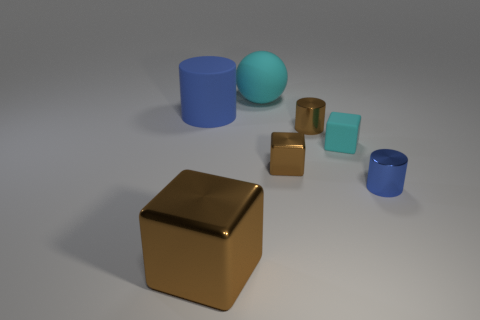Add 2 large blue rubber things. How many objects exist? 9 Subtract all cylinders. How many objects are left? 4 Subtract 2 brown blocks. How many objects are left? 5 Subtract all large red matte cylinders. Subtract all tiny brown cylinders. How many objects are left? 6 Add 3 brown metallic cylinders. How many brown metallic cylinders are left? 4 Add 1 small cyan rubber objects. How many small cyan rubber objects exist? 2 